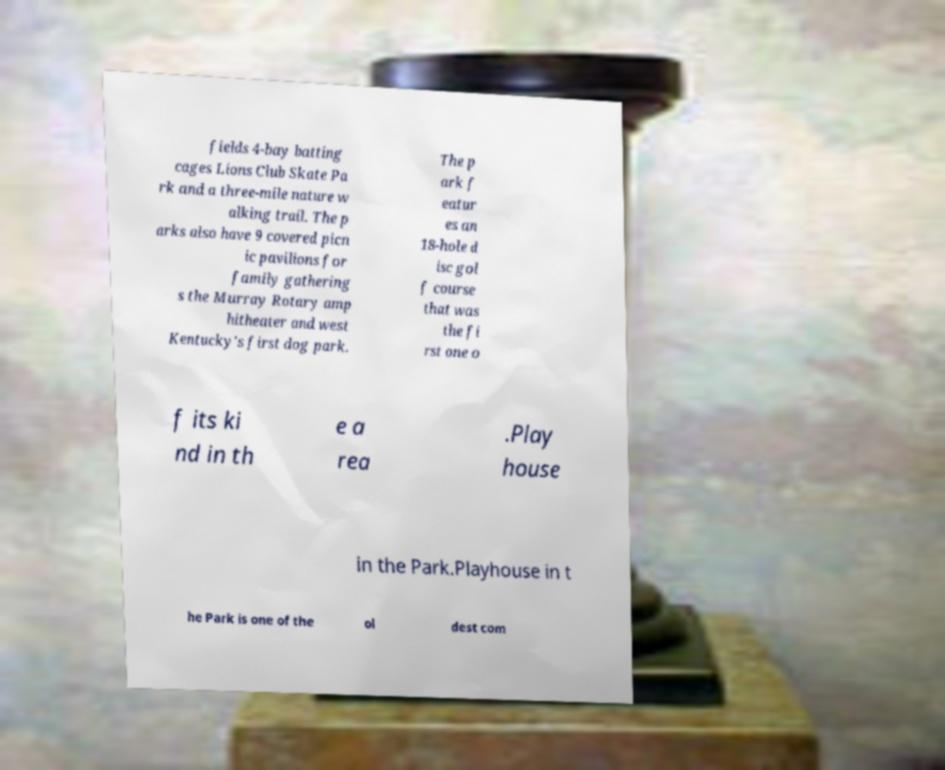Could you extract and type out the text from this image? fields 4-bay batting cages Lions Club Skate Pa rk and a three-mile nature w alking trail. The p arks also have 9 covered picn ic pavilions for family gathering s the Murray Rotary amp hitheater and west Kentucky's first dog park. The p ark f eatur es an 18-hole d isc gol f course that was the fi rst one o f its ki nd in th e a rea .Play house in the Park.Playhouse in t he Park is one of the ol dest com 